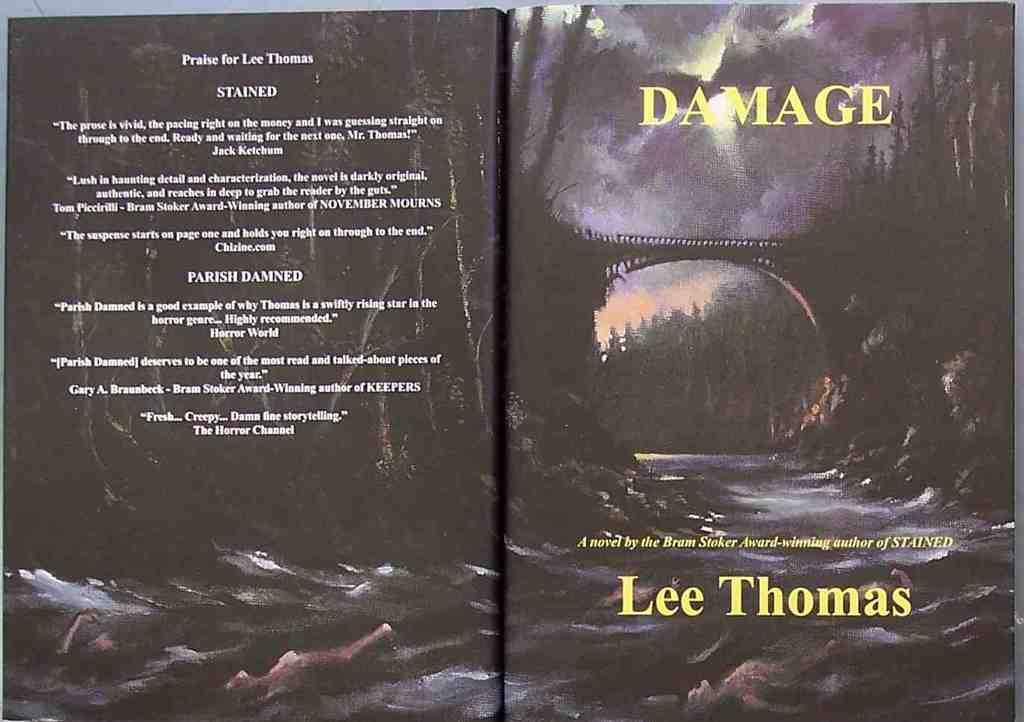<image>
Relay a brief, clear account of the picture shown. a book with the title Damage on the top of it 